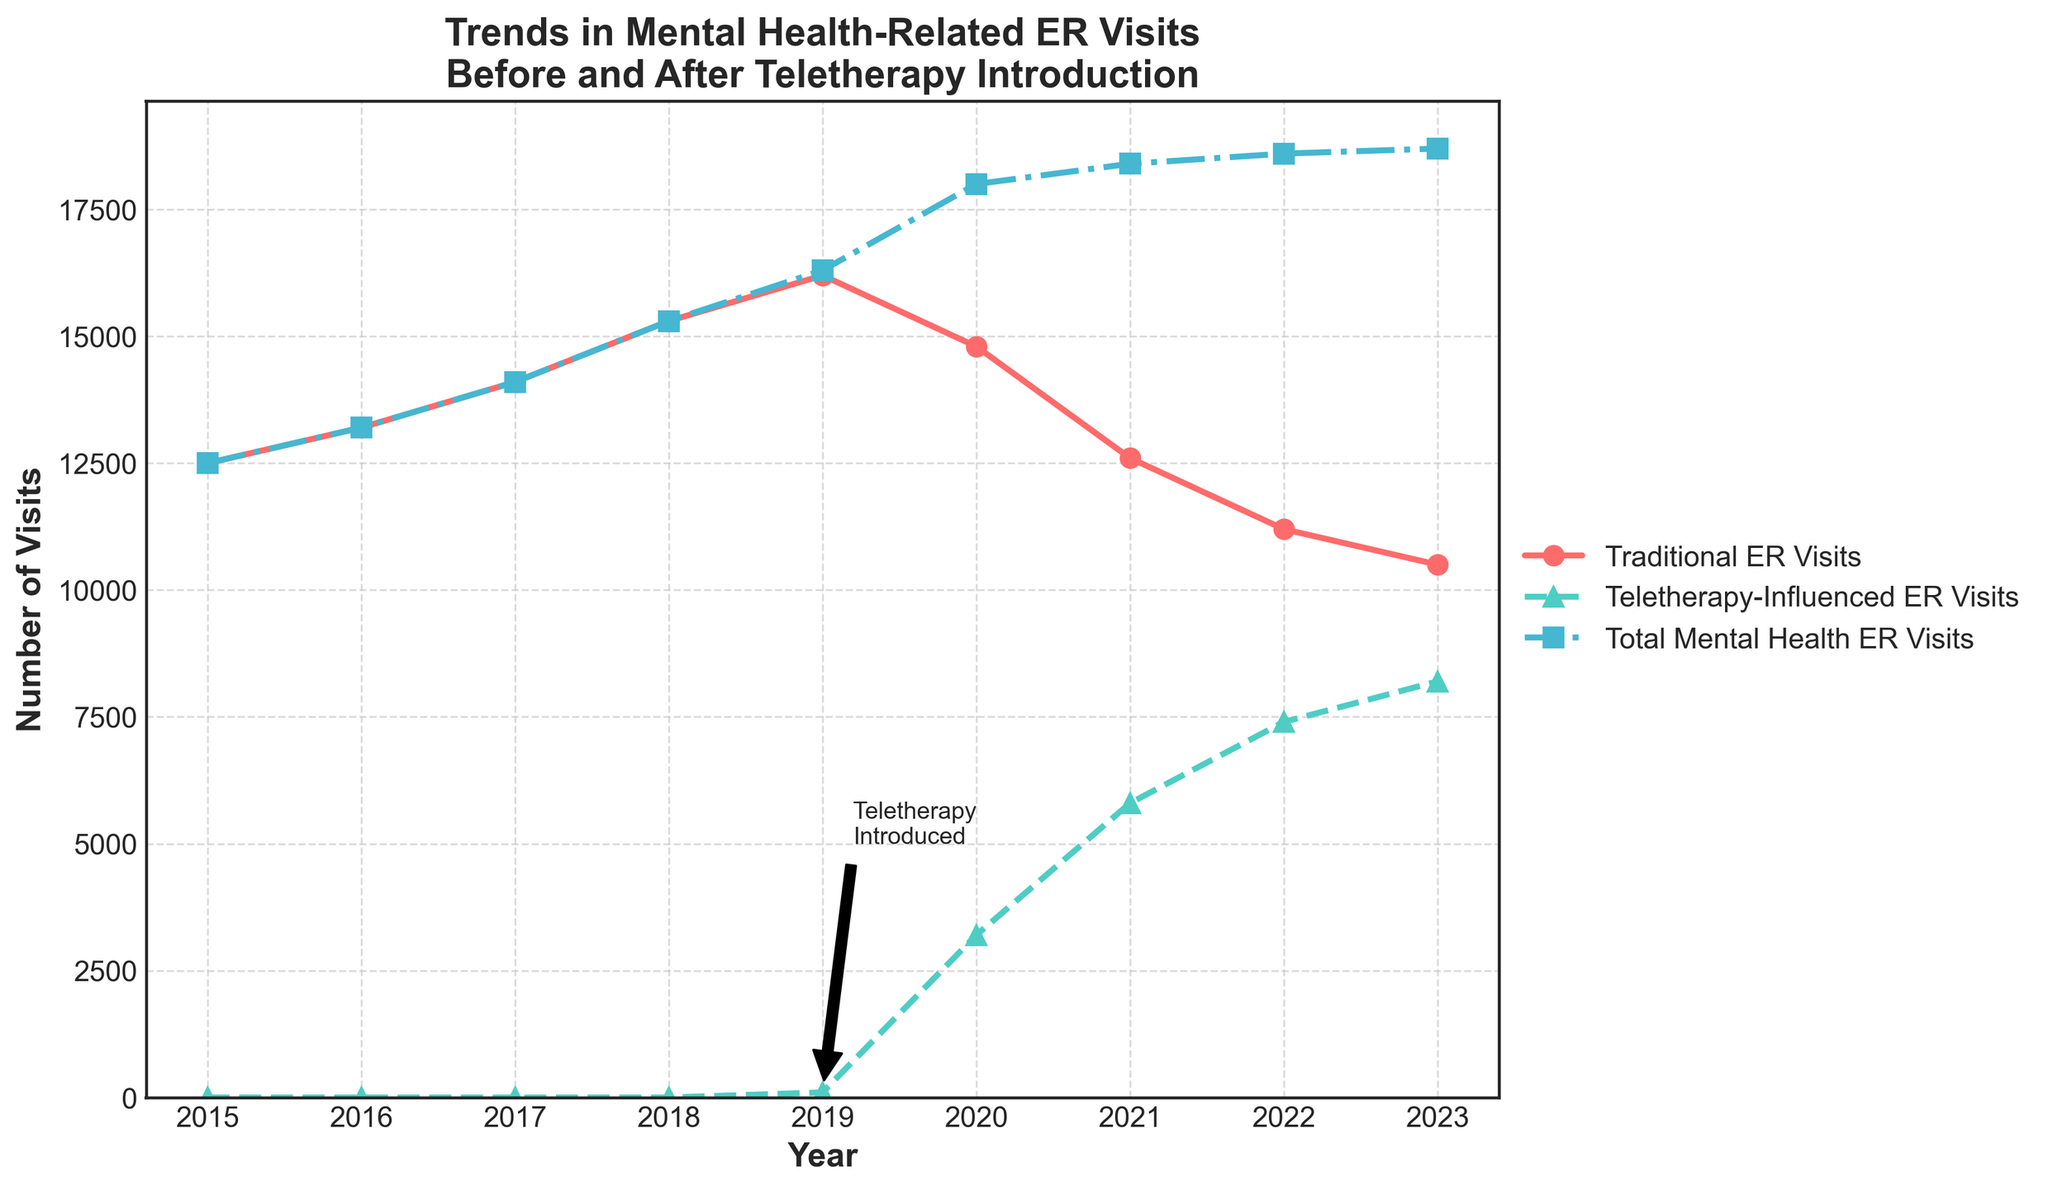Which year had the highest number of total mental health ER visits? The total mental health ER visits are indicated by the line with square markers. By examining the trend, the highest number lies at the peak in 2023.
Answer: 2023 How did the number of traditional ER visits change from 2018 to 2020? In 2018, traditional ER visits were 15,300, and in 2020, they were 14,800. The change can be calculated as 14,800 - 15,300 = -500.
Answer: Decreased by 500 What was the difference between teletherapy-influenced ER visits and traditional ER visits in 2021? In 2021, teletherapy-influenced visits were 5800 and traditional visits were 12600. The difference is 12600 - 5800 = 6800.
Answer: 6800 Which year saw the introduction of teletherapy services according to the annotation? The annotation "Teletherapy Introduced" points to the year 2019.
Answer: 2019 Has the number of traditional ER visits been increasing or decreasing since the introduction of teletherapy services? From 2019 to 2023, the traditional ER visits have been continuously decreasing, which is evident from the downward slope of the red line after 2019.
Answer: Decreasing In which year did total mental health ER visits surpass 18,000? The plot indicates that total mental health ER visits went beyond 18,000 in 2020.
Answer: 2020 Between 2020 and 2023, which year had the highest number of teletherapy-influenced ER visits? The teal-colored line with triangular markers shows that the highest point is in 2023, with 8200 visits.
Answer: 2023 What's the average number of total mental health ER visits from 2019 to 2023? Sum the totals from 2019 to 2023 (16300, 18000, 18400, 18600, 18700) to get 90000 and divide by 5, giving an average of 90000/5 = 18000.
Answer: 18000 How many more total mental health ER visits were there in 2023 compared to 2015? Total visits in 2023 were 18700, and in 2015 they were 12500. The difference is 18700 - 12500 = 6200.
Answer: 6200 Which year had the smallest number of traditional ER visits after the introduction of teletherapy services? After teletherapy was introduced in 2019, the smallest number of traditional ER visits occurred in 2023, with 10500 visits.
Answer: 2023 